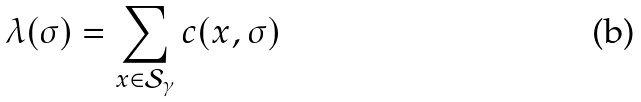Convert formula to latex. <formula><loc_0><loc_0><loc_500><loc_500>\lambda ( \sigma ) = \sum _ { x \in \mathcal { S } _ { \gamma } } c ( x , \sigma )</formula> 